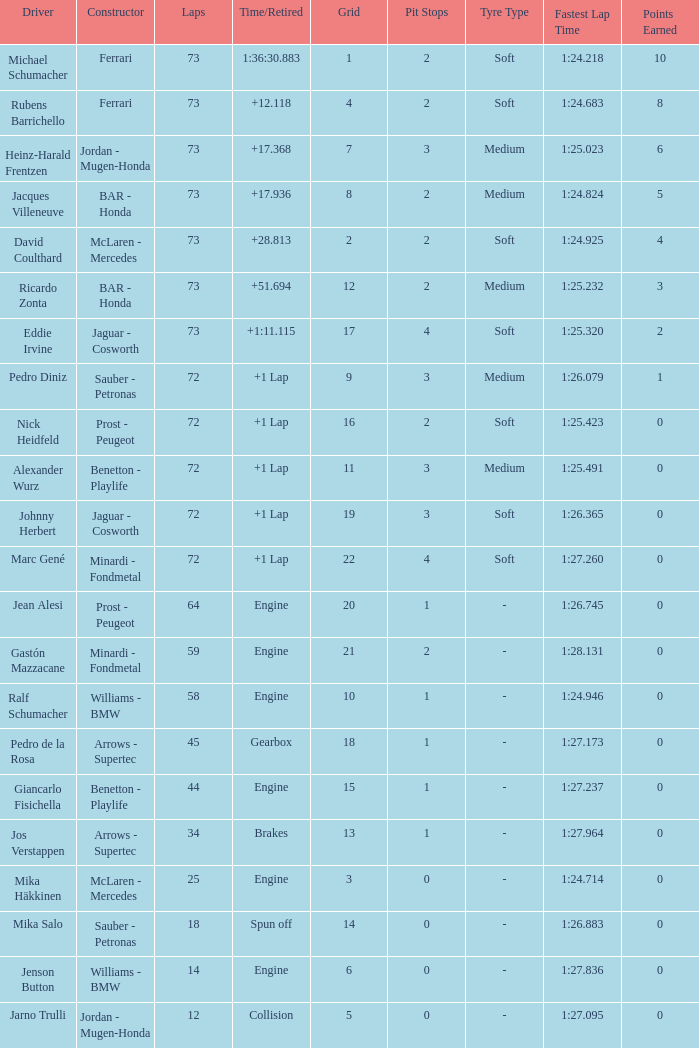Parse the table in full. {'header': ['Driver', 'Constructor', 'Laps', 'Time/Retired', 'Grid', 'Pit Stops', 'Tyre Type', 'Fastest Lap Time', 'Points Earned'], 'rows': [['Michael Schumacher', 'Ferrari', '73', '1:36:30.883', '1', '2', 'Soft', '1:24.218', '10'], ['Rubens Barrichello', 'Ferrari', '73', '+12.118', '4', '2', 'Soft', '1:24.683', '8'], ['Heinz-Harald Frentzen', 'Jordan - Mugen-Honda', '73', '+17.368', '7', '3', 'Medium', '1:25.023', '6'], ['Jacques Villeneuve', 'BAR - Honda', '73', '+17.936', '8', '2', 'Medium', '1:24.824', '5'], ['David Coulthard', 'McLaren - Mercedes', '73', '+28.813', '2', '2', 'Soft', '1:24.925', '4'], ['Ricardo Zonta', 'BAR - Honda', '73', '+51.694', '12', '2', 'Medium', '1:25.232', '3'], ['Eddie Irvine', 'Jaguar - Cosworth', '73', '+1:11.115', '17', '4', 'Soft', '1:25.320', '2'], ['Pedro Diniz', 'Sauber - Petronas', '72', '+1 Lap', '9', '3', 'Medium', '1:26.079', '1'], ['Nick Heidfeld', 'Prost - Peugeot', '72', '+1 Lap', '16', '2', 'Soft', '1:25.423', '0'], ['Alexander Wurz', 'Benetton - Playlife', '72', '+1 Lap', '11', '3', 'Medium', '1:25.491', '0'], ['Johnny Herbert', 'Jaguar - Cosworth', '72', '+1 Lap', '19', '3', 'Soft', '1:26.365', '0'], ['Marc Gené', 'Minardi - Fondmetal', '72', '+1 Lap', '22', '4', 'Soft', '1:27.260', '0'], ['Jean Alesi', 'Prost - Peugeot', '64', 'Engine', '20', '1', '-', '1:26.745', '0'], ['Gastón Mazzacane', 'Minardi - Fondmetal', '59', 'Engine', '21', '2', '-', '1:28.131', '0'], ['Ralf Schumacher', 'Williams - BMW', '58', 'Engine', '10', '1', '-', '1:24.946', '0'], ['Pedro de la Rosa', 'Arrows - Supertec', '45', 'Gearbox', '18', '1', '-', '1:27.173', '0'], ['Giancarlo Fisichella', 'Benetton - Playlife', '44', 'Engine', '15', '1', '-', '1:27.237', '0'], ['Jos Verstappen', 'Arrows - Supertec', '34', 'Brakes', '13', '1', '-', '1:27.964', '0'], ['Mika Häkkinen', 'McLaren - Mercedes', '25', 'Engine', '3', '0', '-', '1:24.714', '0'], ['Mika Salo', 'Sauber - Petronas', '18', 'Spun off', '14', '0', '-', '1:26.883', '0'], ['Jenson Button', 'Williams - BMW', '14', 'Engine', '6', '0', '-', '1:27.836', '0'], ['Jarno Trulli', 'Jordan - Mugen-Honda', '12', 'Collision', '5', '0', '-', '1:27.095', '0']]} How many laps did Jos Verstappen do on Grid 2? 34.0. 